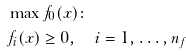Convert formula to latex. <formula><loc_0><loc_0><loc_500><loc_500>& \max f _ { 0 } ( x ) \colon \\ & f _ { i } ( x ) \geq 0 , \quad i = 1 , \dots , n _ { f }</formula> 